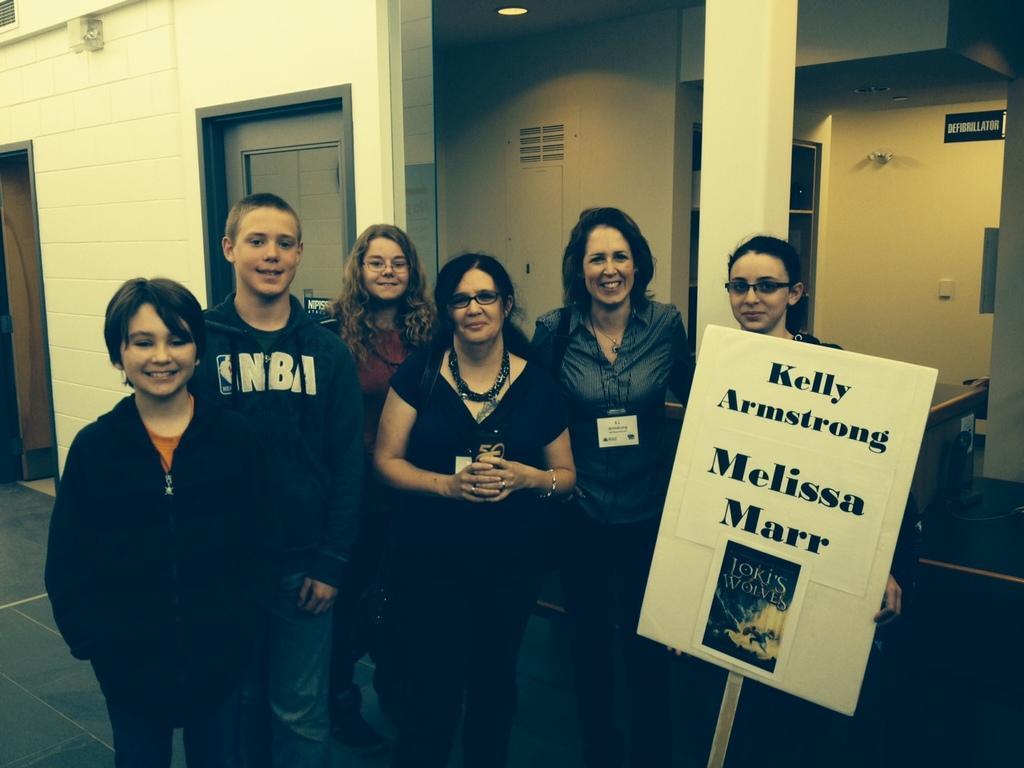Can you describe this image briefly? In this picture we can see a group of people standing on the floor and smiling and a woman holding a board with her hand and on this board we can see posters and at the back of them we can see a name board, doors, pillars, light and some objects. 